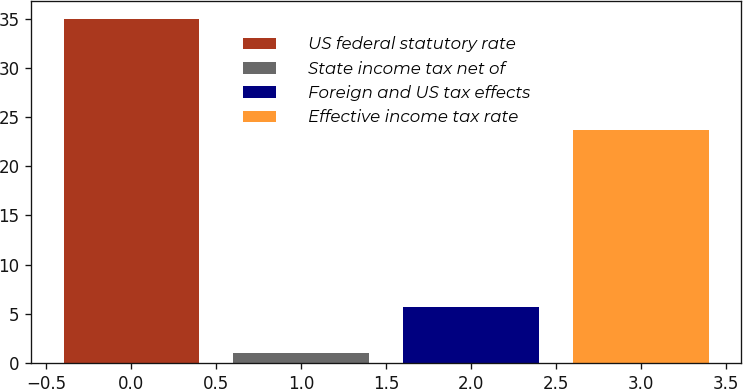Convert chart. <chart><loc_0><loc_0><loc_500><loc_500><bar_chart><fcel>US federal statutory rate<fcel>State income tax net of<fcel>Foreign and US tax effects<fcel>Effective income tax rate<nl><fcel>35<fcel>1<fcel>5.7<fcel>23.7<nl></chart> 